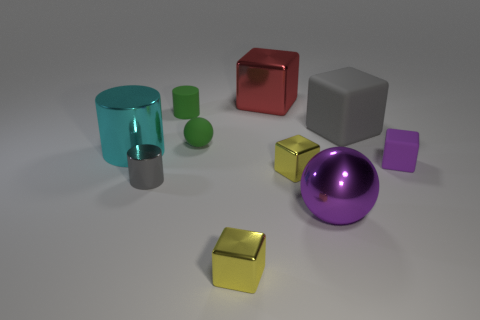Subtract all yellow cylinders. How many yellow blocks are left? 2 Subtract 1 cylinders. How many cylinders are left? 2 Subtract all red blocks. How many blocks are left? 4 Subtract all tiny matte blocks. How many blocks are left? 4 Subtract all purple cubes. Subtract all yellow cylinders. How many cubes are left? 4 Subtract all cylinders. How many objects are left? 7 Add 6 big objects. How many big objects are left? 10 Add 8 tiny yellow cubes. How many tiny yellow cubes exist? 10 Subtract 0 yellow spheres. How many objects are left? 10 Subtract all tiny green cylinders. Subtract all large cubes. How many objects are left? 7 